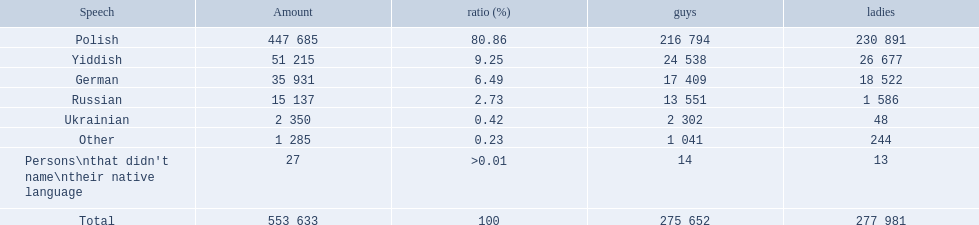What was the highest percentage of one language spoken by the plock governorate? 80.86. What language was spoken by 80.86 percent of the people? Polish. 